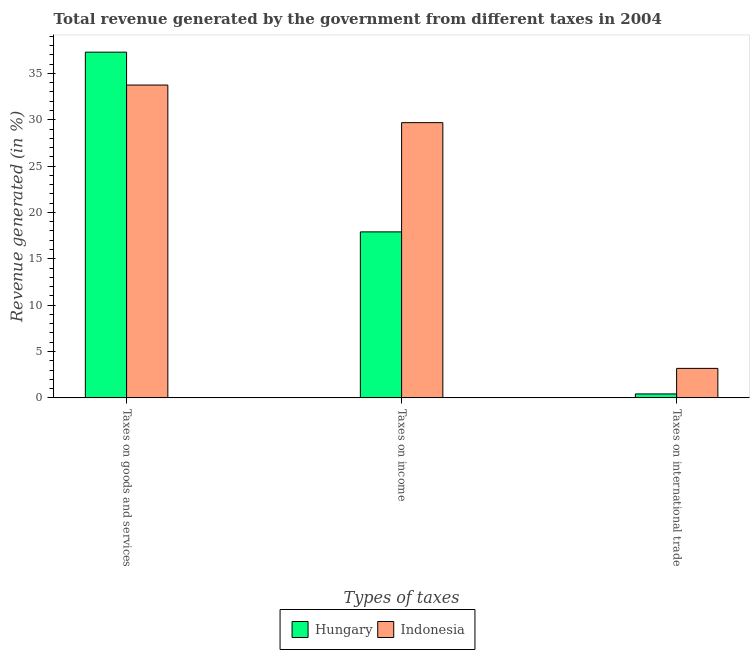How many different coloured bars are there?
Offer a terse response. 2. How many groups of bars are there?
Give a very brief answer. 3. Are the number of bars per tick equal to the number of legend labels?
Ensure brevity in your answer.  Yes. Are the number of bars on each tick of the X-axis equal?
Offer a terse response. Yes. What is the label of the 2nd group of bars from the left?
Ensure brevity in your answer.  Taxes on income. What is the percentage of revenue generated by taxes on income in Hungary?
Keep it short and to the point. 17.9. Across all countries, what is the maximum percentage of revenue generated by taxes on goods and services?
Your response must be concise. 37.29. Across all countries, what is the minimum percentage of revenue generated by taxes on goods and services?
Your response must be concise. 33.74. In which country was the percentage of revenue generated by taxes on goods and services maximum?
Offer a very short reply. Hungary. In which country was the percentage of revenue generated by tax on international trade minimum?
Give a very brief answer. Hungary. What is the total percentage of revenue generated by taxes on goods and services in the graph?
Keep it short and to the point. 71.03. What is the difference between the percentage of revenue generated by taxes on goods and services in Hungary and that in Indonesia?
Make the answer very short. 3.55. What is the difference between the percentage of revenue generated by taxes on income in Indonesia and the percentage of revenue generated by tax on international trade in Hungary?
Provide a short and direct response. 29.26. What is the average percentage of revenue generated by taxes on goods and services per country?
Provide a short and direct response. 35.52. What is the difference between the percentage of revenue generated by tax on international trade and percentage of revenue generated by taxes on goods and services in Hungary?
Provide a short and direct response. -36.87. What is the ratio of the percentage of revenue generated by taxes on goods and services in Hungary to that in Indonesia?
Offer a very short reply. 1.11. Is the difference between the percentage of revenue generated by taxes on goods and services in Hungary and Indonesia greater than the difference between the percentage of revenue generated by taxes on income in Hungary and Indonesia?
Provide a short and direct response. Yes. What is the difference between the highest and the second highest percentage of revenue generated by taxes on income?
Offer a very short reply. 11.78. What is the difference between the highest and the lowest percentage of revenue generated by tax on international trade?
Provide a succinct answer. 2.76. In how many countries, is the percentage of revenue generated by taxes on income greater than the average percentage of revenue generated by taxes on income taken over all countries?
Give a very brief answer. 1. Is the sum of the percentage of revenue generated by taxes on income in Hungary and Indonesia greater than the maximum percentage of revenue generated by taxes on goods and services across all countries?
Make the answer very short. Yes. What does the 1st bar from the left in Taxes on income represents?
Offer a terse response. Hungary. What does the 2nd bar from the right in Taxes on income represents?
Offer a very short reply. Hungary. Is it the case that in every country, the sum of the percentage of revenue generated by taxes on goods and services and percentage of revenue generated by taxes on income is greater than the percentage of revenue generated by tax on international trade?
Provide a succinct answer. Yes. How many countries are there in the graph?
Keep it short and to the point. 2. What is the difference between two consecutive major ticks on the Y-axis?
Your answer should be very brief. 5. Where does the legend appear in the graph?
Provide a short and direct response. Bottom center. How many legend labels are there?
Your answer should be compact. 2. What is the title of the graph?
Offer a very short reply. Total revenue generated by the government from different taxes in 2004. What is the label or title of the X-axis?
Provide a succinct answer. Types of taxes. What is the label or title of the Y-axis?
Your answer should be compact. Revenue generated (in %). What is the Revenue generated (in %) of Hungary in Taxes on goods and services?
Offer a terse response. 37.29. What is the Revenue generated (in %) in Indonesia in Taxes on goods and services?
Offer a terse response. 33.74. What is the Revenue generated (in %) of Hungary in Taxes on income?
Your answer should be very brief. 17.9. What is the Revenue generated (in %) of Indonesia in Taxes on income?
Your response must be concise. 29.69. What is the Revenue generated (in %) in Hungary in Taxes on international trade?
Offer a terse response. 0.43. What is the Revenue generated (in %) of Indonesia in Taxes on international trade?
Offer a terse response. 3.18. Across all Types of taxes, what is the maximum Revenue generated (in %) in Hungary?
Make the answer very short. 37.29. Across all Types of taxes, what is the maximum Revenue generated (in %) in Indonesia?
Give a very brief answer. 33.74. Across all Types of taxes, what is the minimum Revenue generated (in %) of Hungary?
Ensure brevity in your answer.  0.43. Across all Types of taxes, what is the minimum Revenue generated (in %) of Indonesia?
Your answer should be very brief. 3.18. What is the total Revenue generated (in %) in Hungary in the graph?
Give a very brief answer. 55.62. What is the total Revenue generated (in %) in Indonesia in the graph?
Your answer should be compact. 66.61. What is the difference between the Revenue generated (in %) of Hungary in Taxes on goods and services and that in Taxes on income?
Make the answer very short. 19.39. What is the difference between the Revenue generated (in %) of Indonesia in Taxes on goods and services and that in Taxes on income?
Offer a terse response. 4.05. What is the difference between the Revenue generated (in %) in Hungary in Taxes on goods and services and that in Taxes on international trade?
Give a very brief answer. 36.87. What is the difference between the Revenue generated (in %) of Indonesia in Taxes on goods and services and that in Taxes on international trade?
Provide a succinct answer. 30.56. What is the difference between the Revenue generated (in %) of Hungary in Taxes on income and that in Taxes on international trade?
Your response must be concise. 17.48. What is the difference between the Revenue generated (in %) of Indonesia in Taxes on income and that in Taxes on international trade?
Provide a short and direct response. 26.51. What is the difference between the Revenue generated (in %) in Hungary in Taxes on goods and services and the Revenue generated (in %) in Indonesia in Taxes on income?
Provide a succinct answer. 7.6. What is the difference between the Revenue generated (in %) of Hungary in Taxes on goods and services and the Revenue generated (in %) of Indonesia in Taxes on international trade?
Ensure brevity in your answer.  34.11. What is the difference between the Revenue generated (in %) of Hungary in Taxes on income and the Revenue generated (in %) of Indonesia in Taxes on international trade?
Your answer should be very brief. 14.72. What is the average Revenue generated (in %) in Hungary per Types of taxes?
Ensure brevity in your answer.  18.54. What is the average Revenue generated (in %) in Indonesia per Types of taxes?
Your response must be concise. 22.2. What is the difference between the Revenue generated (in %) of Hungary and Revenue generated (in %) of Indonesia in Taxes on goods and services?
Make the answer very short. 3.55. What is the difference between the Revenue generated (in %) of Hungary and Revenue generated (in %) of Indonesia in Taxes on income?
Ensure brevity in your answer.  -11.78. What is the difference between the Revenue generated (in %) of Hungary and Revenue generated (in %) of Indonesia in Taxes on international trade?
Your answer should be compact. -2.76. What is the ratio of the Revenue generated (in %) of Hungary in Taxes on goods and services to that in Taxes on income?
Provide a succinct answer. 2.08. What is the ratio of the Revenue generated (in %) of Indonesia in Taxes on goods and services to that in Taxes on income?
Offer a terse response. 1.14. What is the ratio of the Revenue generated (in %) in Hungary in Taxes on goods and services to that in Taxes on international trade?
Offer a terse response. 87.69. What is the ratio of the Revenue generated (in %) in Indonesia in Taxes on goods and services to that in Taxes on international trade?
Provide a succinct answer. 10.61. What is the ratio of the Revenue generated (in %) of Hungary in Taxes on income to that in Taxes on international trade?
Your answer should be very brief. 42.1. What is the ratio of the Revenue generated (in %) in Indonesia in Taxes on income to that in Taxes on international trade?
Provide a short and direct response. 9.33. What is the difference between the highest and the second highest Revenue generated (in %) in Hungary?
Offer a very short reply. 19.39. What is the difference between the highest and the second highest Revenue generated (in %) in Indonesia?
Ensure brevity in your answer.  4.05. What is the difference between the highest and the lowest Revenue generated (in %) of Hungary?
Give a very brief answer. 36.87. What is the difference between the highest and the lowest Revenue generated (in %) of Indonesia?
Your answer should be very brief. 30.56. 